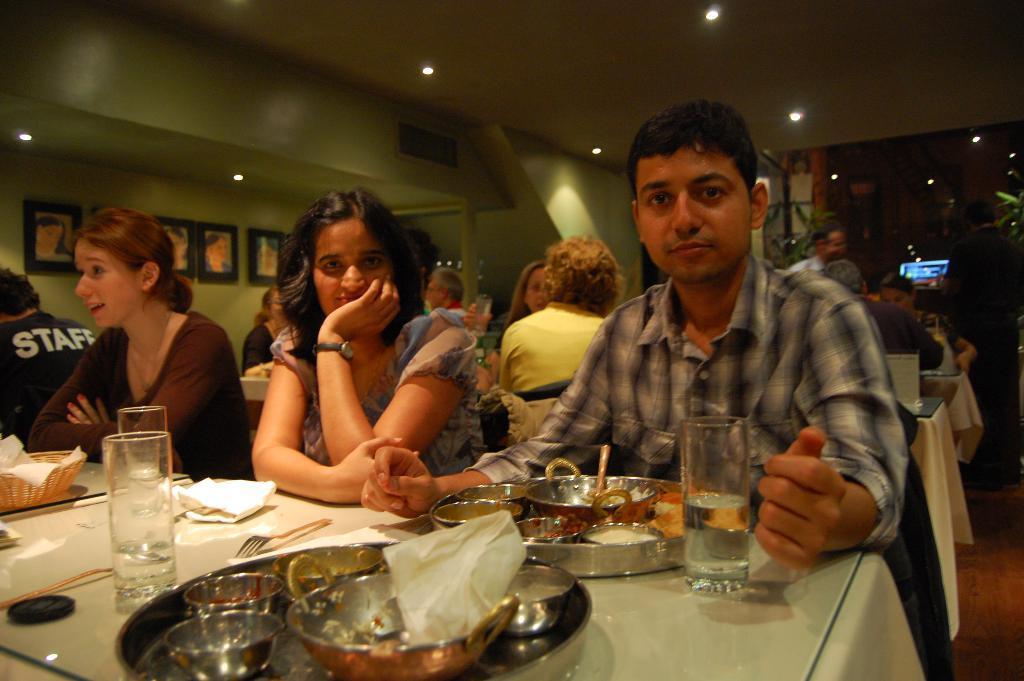Describe this image in one or two sentences. In this image there are a group of persons sitting, there is a man standing, there are tables, there is a table towards the bottom of the image, there are objects on the table, there is a wall towards the left of the image, there are photo frames on the wall, there is a roof towards the top of the image, there are lights, there is a screen, there is an object towards the right of the image, there is a floor towards the right of the image. 